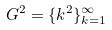<formula> <loc_0><loc_0><loc_500><loc_500>G ^ { 2 } = \{ k ^ { 2 } \} _ { k = 1 } ^ { \infty }</formula> 